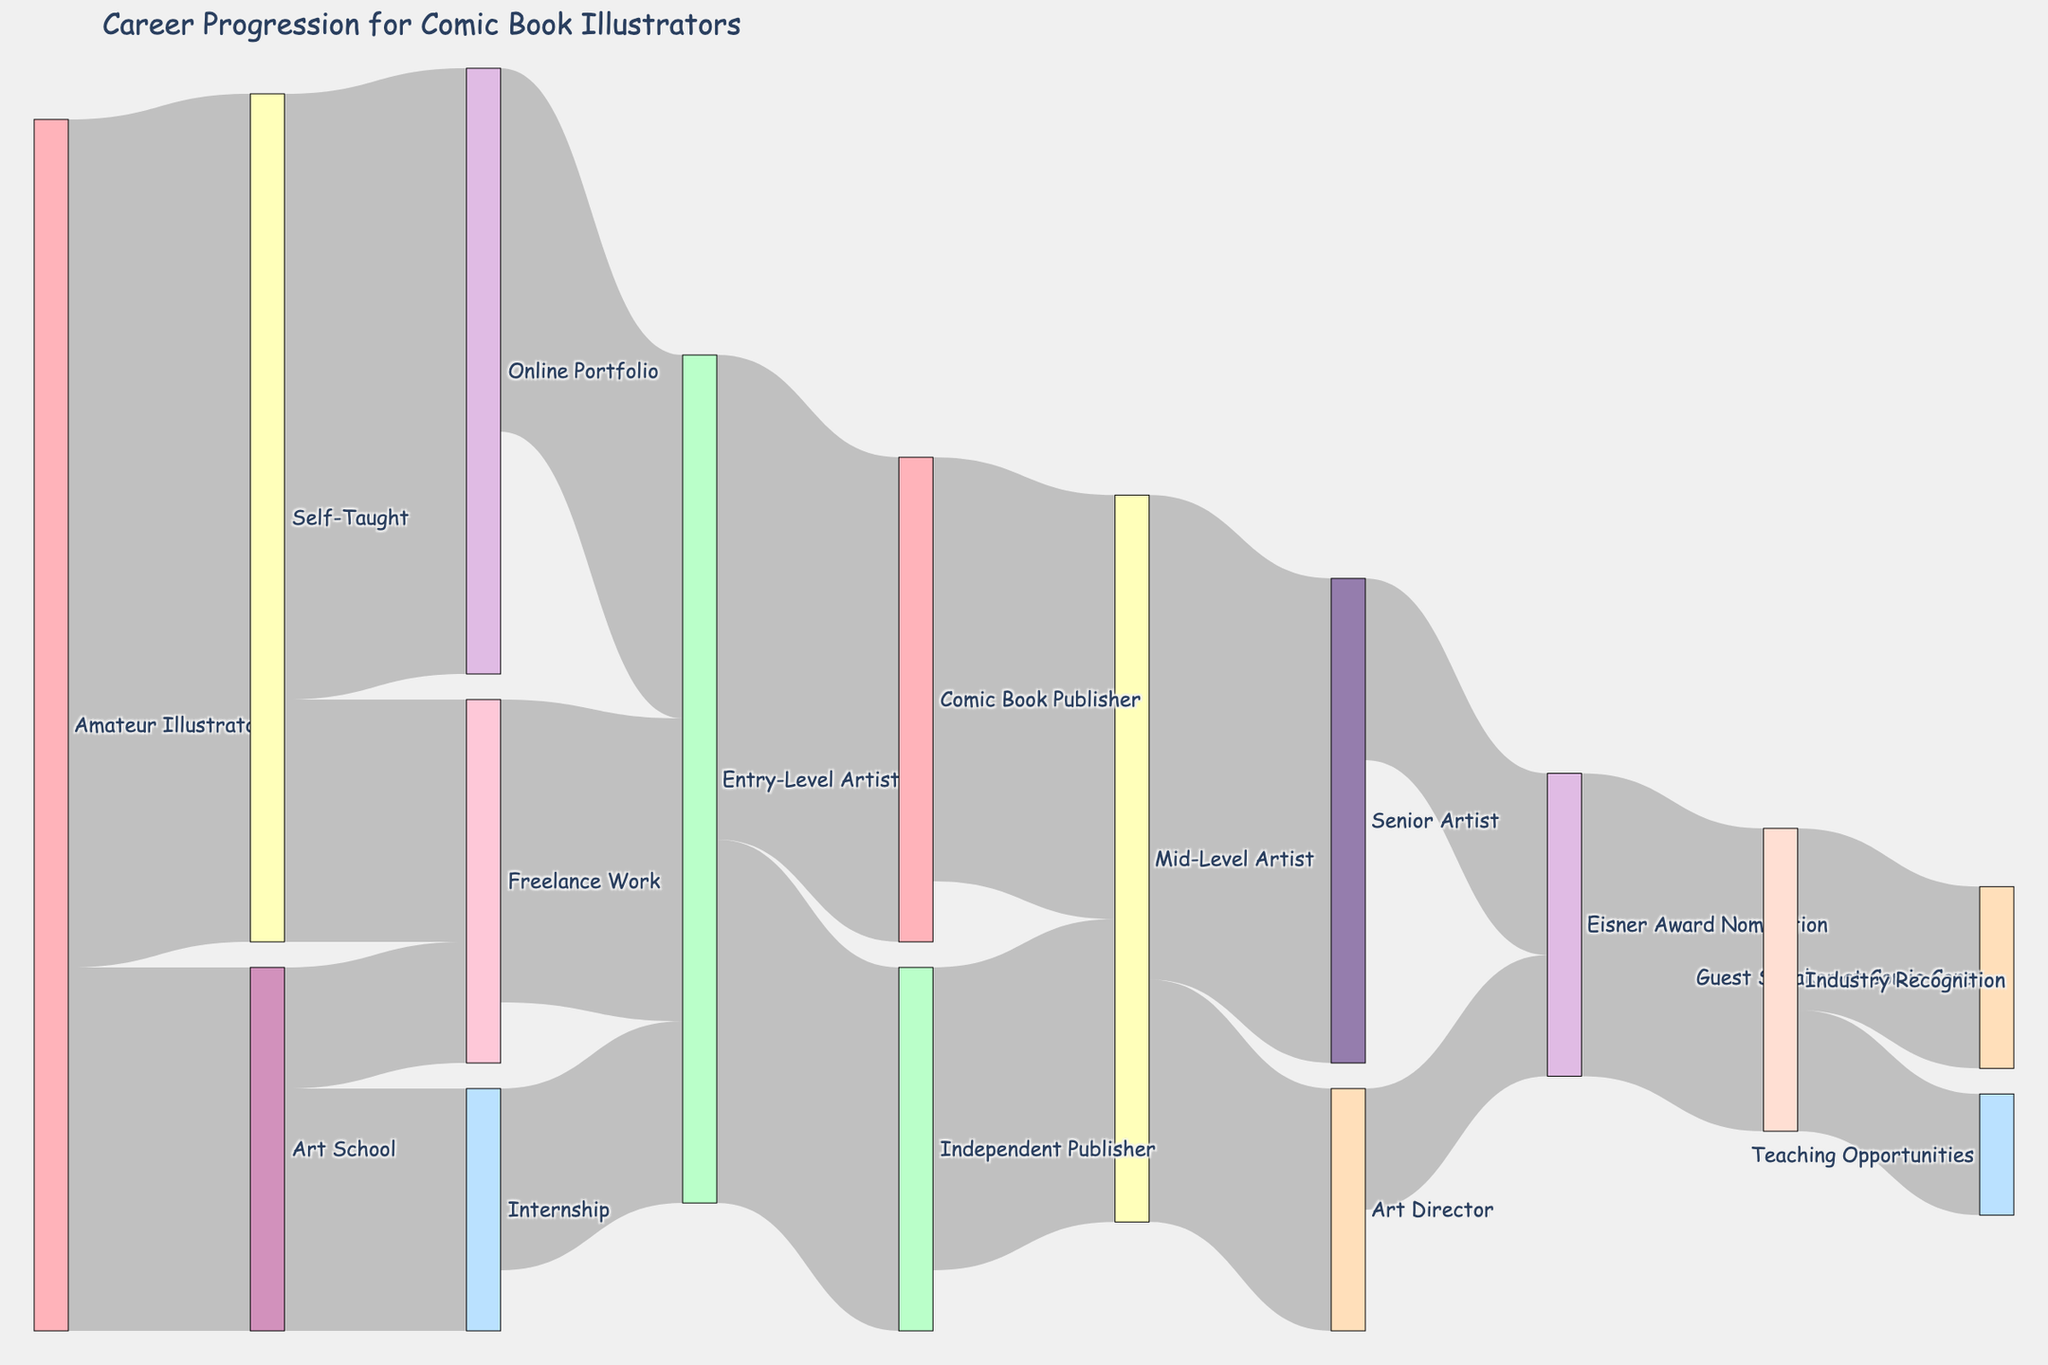What is the most common initial path for amateur illustrators? The Sankey diagram shows that 70 amateur illustrators chose the self-taught path, while 30 went to art school, making self-taught the most common initial path.
Answer: Self-Taught How many comic book illustrators progressed from self-taught to entry-level artist? According to the Sankey diagram, 50 self-taught illustrators created online portfolios, and out of those, 30 became entry-level artists directly, while 20 went freelance, and 25 freelance illustrators also became entry-level artists. Adding those from freelance (20 freelance -> entry-level), the total is 30 + 25 = 55.
Answer: 55 Which stage has the highest number of illustrators advancing from entry-level artist? The Sankey diagram shows 40 illustrators moving from entry-level artist to comic book publisher, which is the highest number compared to 30 moving to independent publisher.
Answer: Comic Book Publisher What path leads to the highest number of Eisner Award Nominations? The diagram reveals that 15 senior artists and 10 art directors were nominated, totalling 25 nominations, all from these two paths.
Answer: Senior Artist and Art Director What percentage of professional illustrators reach industry recognition through Eisner Award nominations? The Sankey diagram shows that 25 illustrators received industry recognition through Eisner Award Nominations. The professional stages preceding Eisner Award nominations (senior artist and art director) total 50 professionals, so (25/50) * 100% = 50%.
Answer: 50% What is the combined number of illustrators who reach freelance work from both art school and self-taught paths? Referring to the diagram: 10 illustrators moved from art school to freelance work, and 20 moved from self-taught to freelance work, summing up to 10 + 20 = 30.
Answer: 30 How many illustrators achieve teaching opportunities through industry recognition? According to the diagram, 10 illustrators with industry recognition receive teaching opportunities.
Answer: 10 Which path has more illustrators progressing to mid-level artist: comic book publisher or independent publisher? The Sankey diagram depicts 35 illustrators progressing from a comic book publisher to a mid-level artist compared to 25 from an independent publisher.
Answer: Comic Book Publisher What is the total number of illustrators who start as amateur illustrators and move on to professional status through art school? According to the diagram: 30 begin at art school; 20 go to internship, 15 to entry-level, 40 (entry-level to comic book publisher), 35 to mid-level total 35 from comic book publisher or independent publisher lead to mid-level artists, and some to senior artists (40) or art director (20), summing these values provides an estimation of art school-professional transitions.
Answer: 40 How many illustrators eventually become guest speakers at comic cons? Based on the diagram, 15 illustrators with industry recognition ultimately become guest speakers.
Answer: 15 